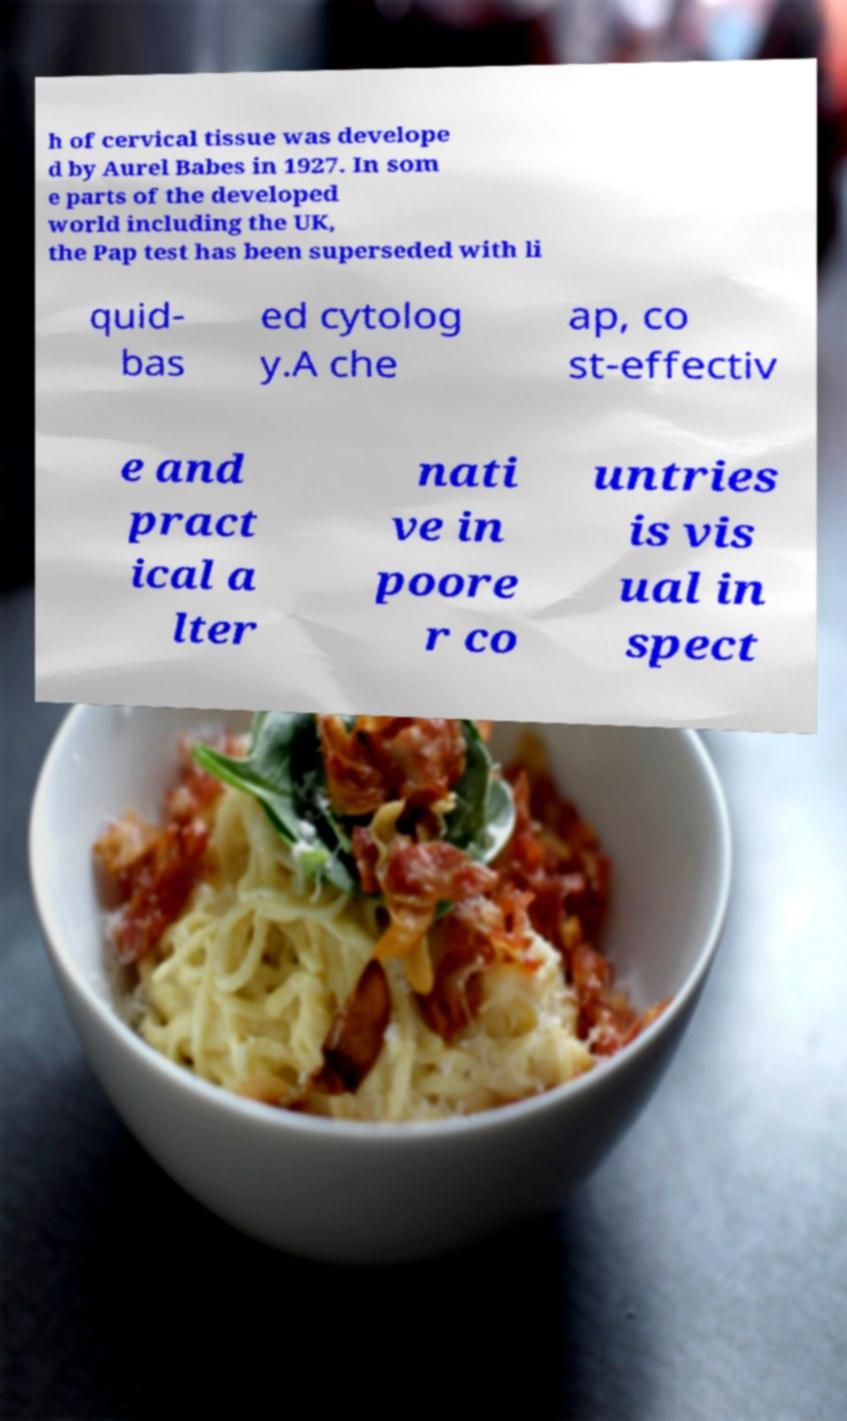For documentation purposes, I need the text within this image transcribed. Could you provide that? h of cervical tissue was develope d by Aurel Babes in 1927. In som e parts of the developed world including the UK, the Pap test has been superseded with li quid- bas ed cytolog y.A che ap, co st-effectiv e and pract ical a lter nati ve in poore r co untries is vis ual in spect 